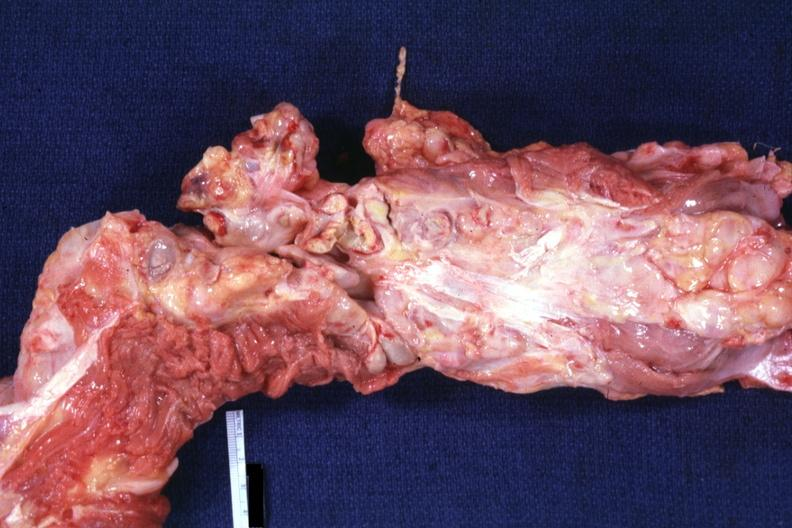what does this image show?
Answer the question using a single word or phrase. Aorta not opened surrounded by large nodes 